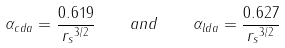Convert formula to latex. <formula><loc_0><loc_0><loc_500><loc_500>\alpha _ { c d a } = \frac { 0 . 6 1 9 } { { r _ { s } } ^ { 3 / 2 } } \quad a n d \quad \alpha _ { l d a } = \frac { 0 . 6 2 7 } { { r _ { s } } ^ { 3 / 2 } }</formula> 